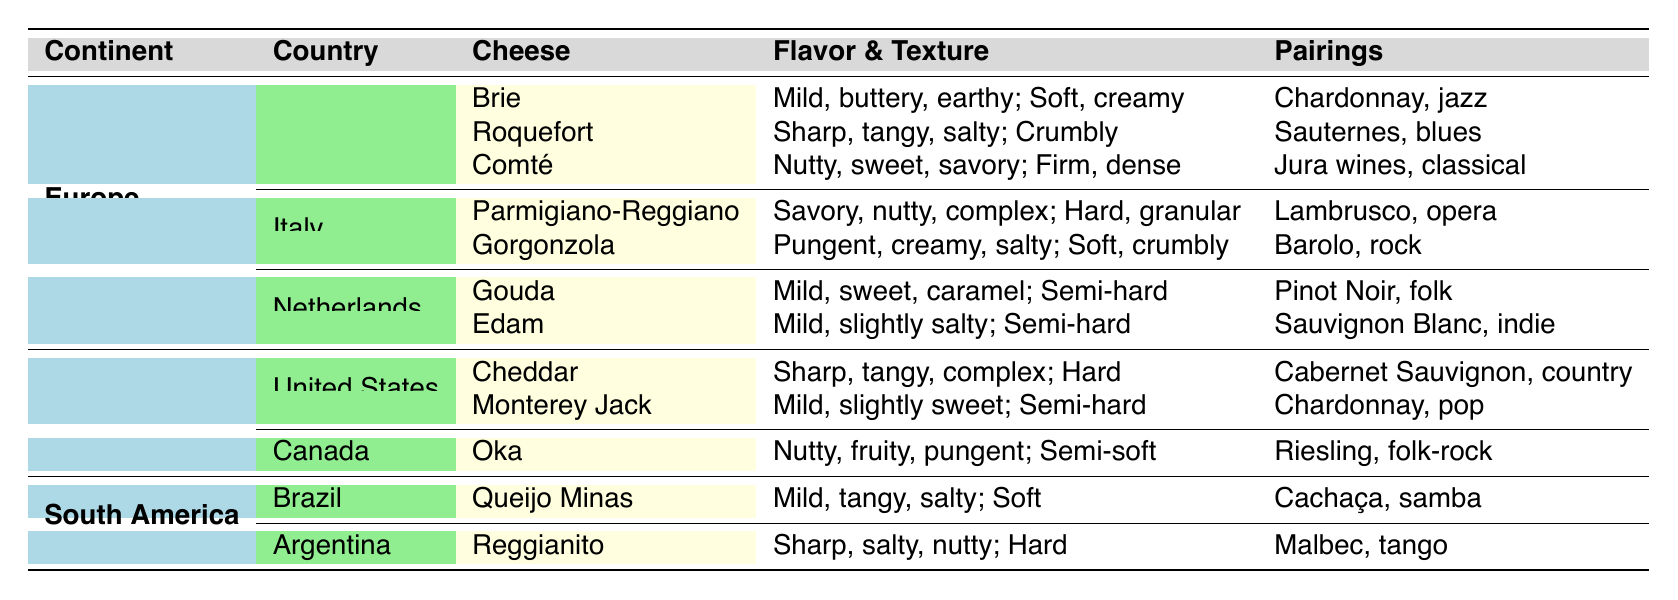What's the flavor profile of Gouda? The table states that Gouda's flavor is described as "Mild, sweet, caramel."
Answer: Mild, sweet, caramel Which country produces Roquefort cheese? The table indicates that Roquefort cheese comes from France.
Answer: France Is there cheese from South America listed in the table? Yes, the table includes cheeses from Brazil and Argentina, specifically Queijo Minas and Reggianito.
Answer: Yes What is the texture of Parmigiano-Reggiano? According to the table, Parmigiano-Reggiano has a "Hard, granular" texture.
Answer: Hard, granular How many types of cheese are listed for Italy? The table shows that there are 2 types of cheese listed for Italy: Parmigiano-Reggiano and Gorgonzola.
Answer: 2 Which cheese from the United States has a sharp and tangy flavor? The table states that Cheddar has a "Sharp, tangy, complex" flavor.
Answer: Cheddar In which continent is Gorgonzola produced? Gorgonzola is produced in Italy, which is located in Europe.
Answer: Europe What cheese pairing is suggested with Oka cheese? The table suggests that Oka cheese pairs well with "Riesling, folk-rock."
Answer: Riesling, folk-rock What is the common flavor profile of cheeses listed from Brazil? Queijo Minas from Brazil is described as having a flavor of "Mild, tangy, salty," which is the only cheese listed from the country.
Answer: Mild, tangy, salty Which country has the most variations of cheese listed in the table? Europe has the most variations, with 7 cheeses listed across France, Italy, and the Netherlands.
Answer: Europe Are there any cheeses listed with a semi-soft texture? Yes, Oka from Canada and Queijo Minas from Brazil are both indicated as having a semi-soft texture.
Answer: Yes Which cheese pairs with Sauternes? The table notes that Roquefort cheese pairs with Sauternes.
Answer: Roquefort What is the flavor profile comparison between Edam and Gouda? Edam has a "Mild, slightly salty" flavor, while Gouda has a "Mild, sweet, caramel" flavor; both have a mild profile but differ in sweetness.
Answer: Edam is slightly salty, Gouda is sweet 